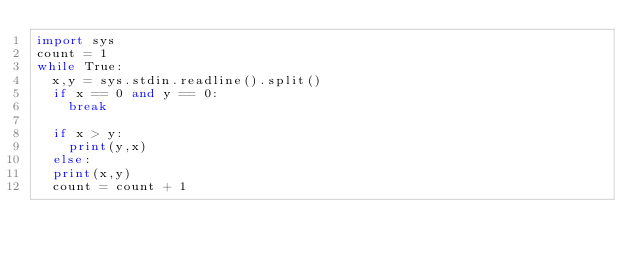Convert code to text. <code><loc_0><loc_0><loc_500><loc_500><_Python_>import sys
count = 1
while True:
  x,y = sys.stdin.readline().split()
  if x == 0 and y == 0:
    break

  if x > y:
    print(y,x)
  else:
  print(x,y)
  count = count + 1  </code> 